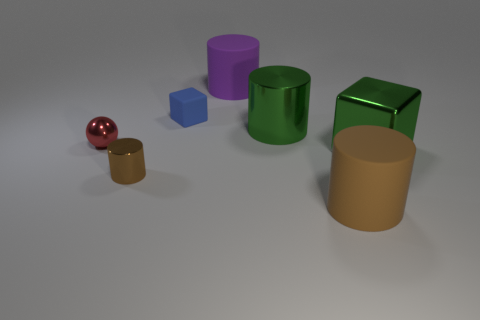What number of other objects are there of the same color as the tiny cylinder?
Make the answer very short. 1. How many cylinders are there?
Your response must be concise. 4. There is a cube that is in front of the tiny red metallic sphere; what is its size?
Your answer should be very brief. Large. How many red matte cylinders have the same size as the blue block?
Provide a succinct answer. 0. There is a object that is left of the small blue rubber thing and behind the green cube; what is it made of?
Give a very brief answer. Metal. There is a purple object that is the same size as the brown matte thing; what is its material?
Offer a very short reply. Rubber. What size is the shiny block behind the brown cylinder left of the big thing behind the matte block?
Your answer should be very brief. Large. What is the size of the green block that is the same material as the tiny brown object?
Provide a succinct answer. Large. Does the brown rubber cylinder have the same size as the green thing that is left of the big brown thing?
Make the answer very short. Yes. The large thing behind the blue rubber object has what shape?
Ensure brevity in your answer.  Cylinder. 